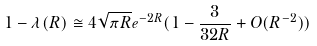<formula> <loc_0><loc_0><loc_500><loc_500>1 - \lambda ( R ) \cong 4 \sqrt { \pi R } e ^ { - 2 R } ( 1 - \frac { 3 } { 3 2 R } + O ( R ^ { - 2 } ) )</formula> 